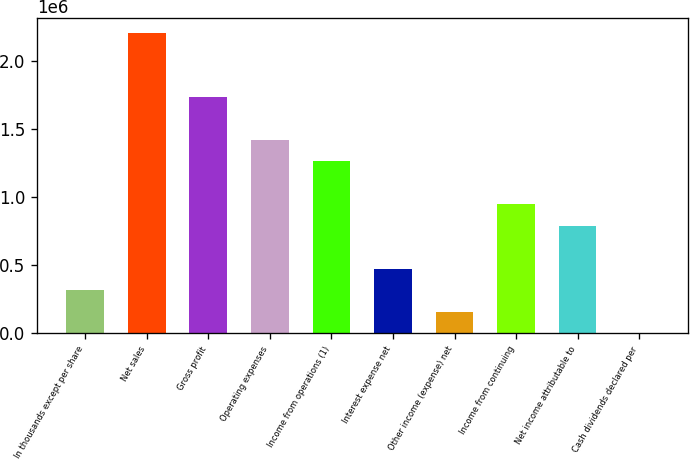<chart> <loc_0><loc_0><loc_500><loc_500><bar_chart><fcel>In thousands except per share<fcel>Net sales<fcel>Gross profit<fcel>Operating expenses<fcel>Income from operations (1)<fcel>Interest expense net<fcel>Other income (expense) net<fcel>Income from continuing<fcel>Net income attributable to<fcel>Cash dividends declared per<nl><fcel>314950<fcel>2.20465e+06<fcel>1.73222e+06<fcel>1.41727e+06<fcel>1.2598e+06<fcel>472425<fcel>157475<fcel>944849<fcel>787375<fcel>0.04<nl></chart> 